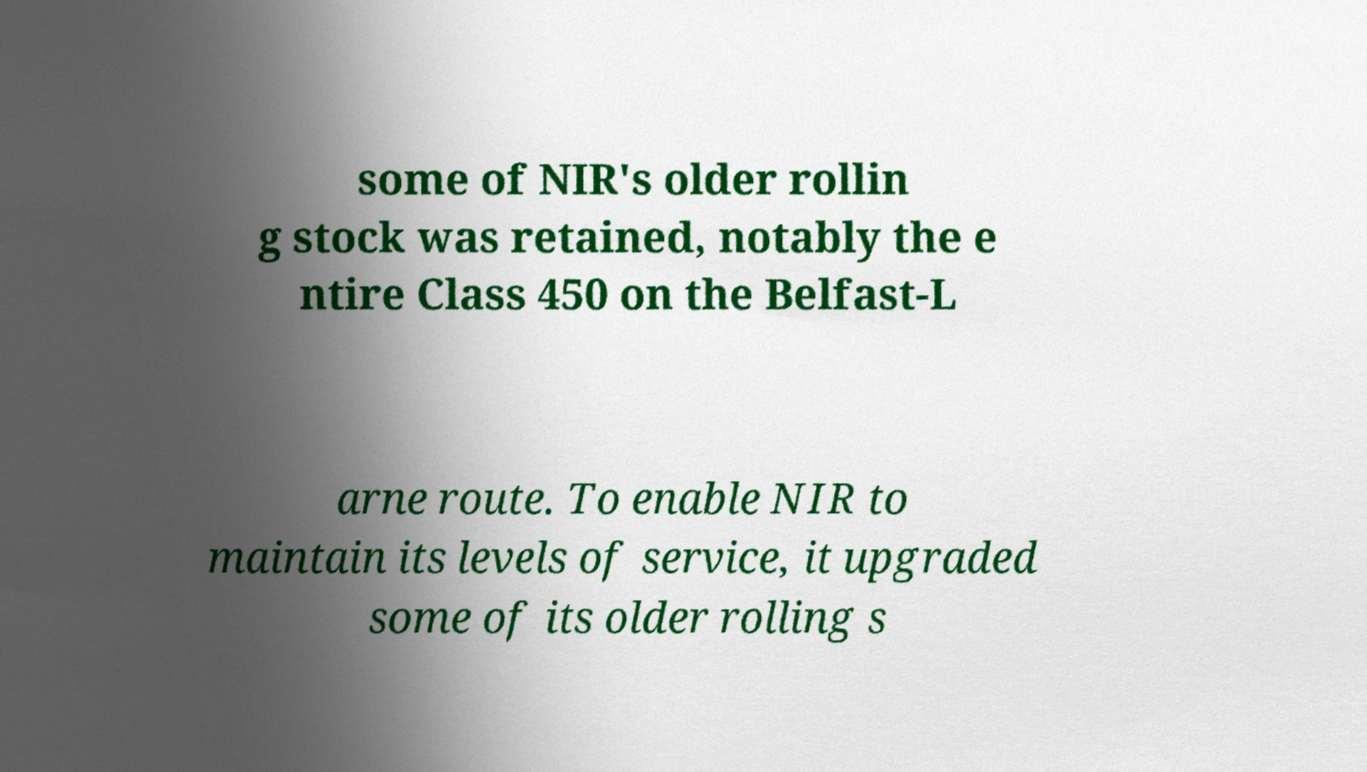Please read and relay the text visible in this image. What does it say? some of NIR's older rollin g stock was retained, notably the e ntire Class 450 on the Belfast-L arne route. To enable NIR to maintain its levels of service, it upgraded some of its older rolling s 